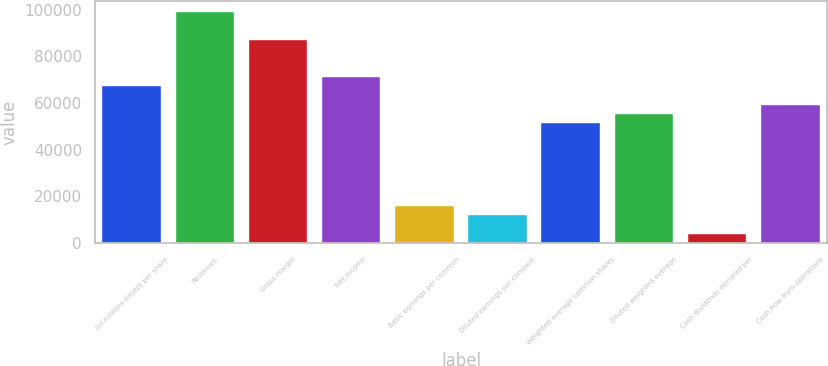Convert chart. <chart><loc_0><loc_0><loc_500><loc_500><bar_chart><fcel>(In millions except per share<fcel>Revenues<fcel>Gross margin<fcel>Net income<fcel>Basic earnings per common<fcel>Diluted earnings per common<fcel>Weighted average common shares<fcel>Diluted weighted average<fcel>Cash dividends declared per<fcel>Cash flow from operations<nl><fcel>67188.9<fcel>98807.1<fcel>86950.2<fcel>71141.2<fcel>15809.4<fcel>11857.1<fcel>51379.8<fcel>55332.1<fcel>3952.57<fcel>59284.3<nl></chart> 